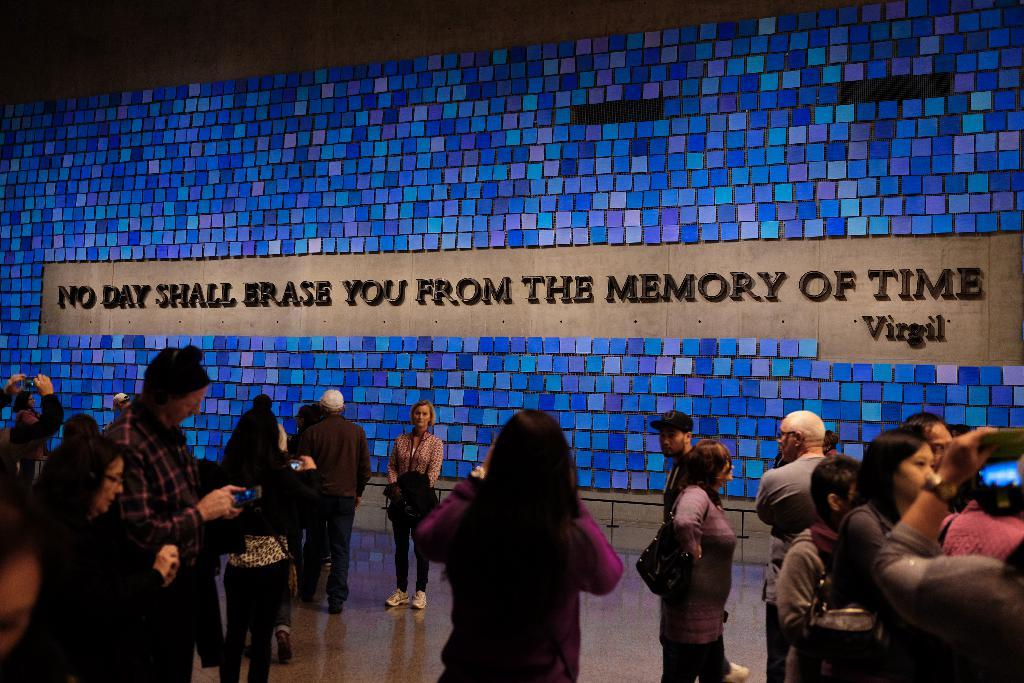What can be seen in the image in terms of human presence? There are people standing in the image. Can you describe the surface on which the people are standing? The people are standing on the floor. What object can be seen on the wall in the image? There is a name board on the wall in the image. What type of jar can be seen on the floor in the image? There is no jar present on the floor in the image. What role does friction play in the image? Friction is not a subject or object that can be observed in the image. Can you describe the cellar in the image? There is no cellar present in the image. 